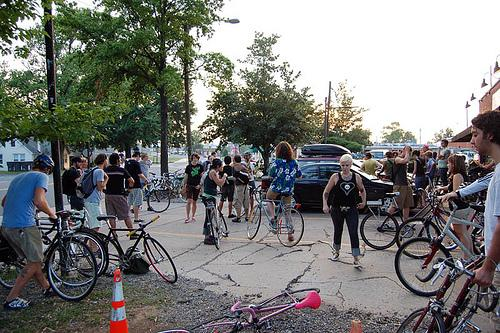Where would you normally find the orange and white thing in the foreground? construction site 